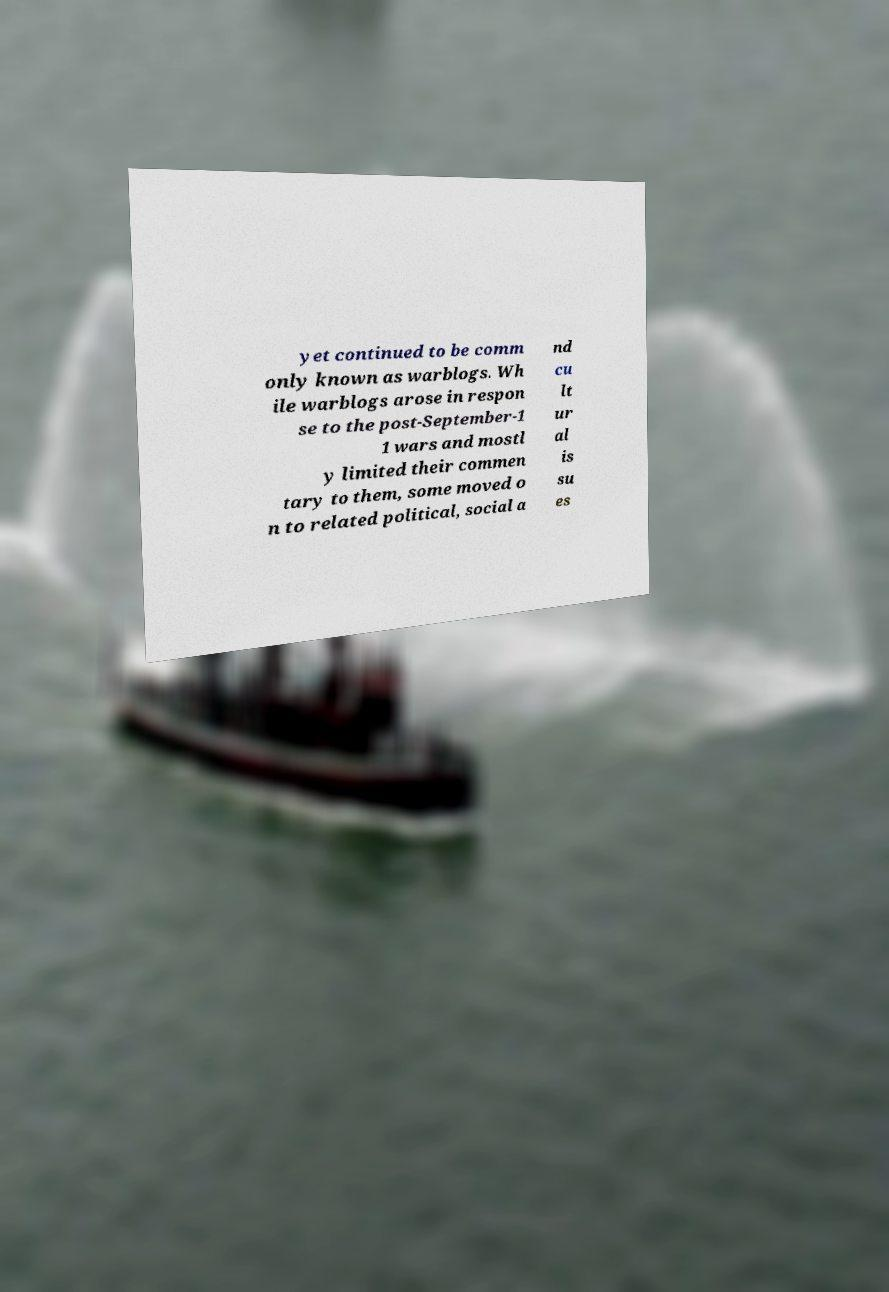Could you extract and type out the text from this image? yet continued to be comm only known as warblogs. Wh ile warblogs arose in respon se to the post-September-1 1 wars and mostl y limited their commen tary to them, some moved o n to related political, social a nd cu lt ur al is su es 